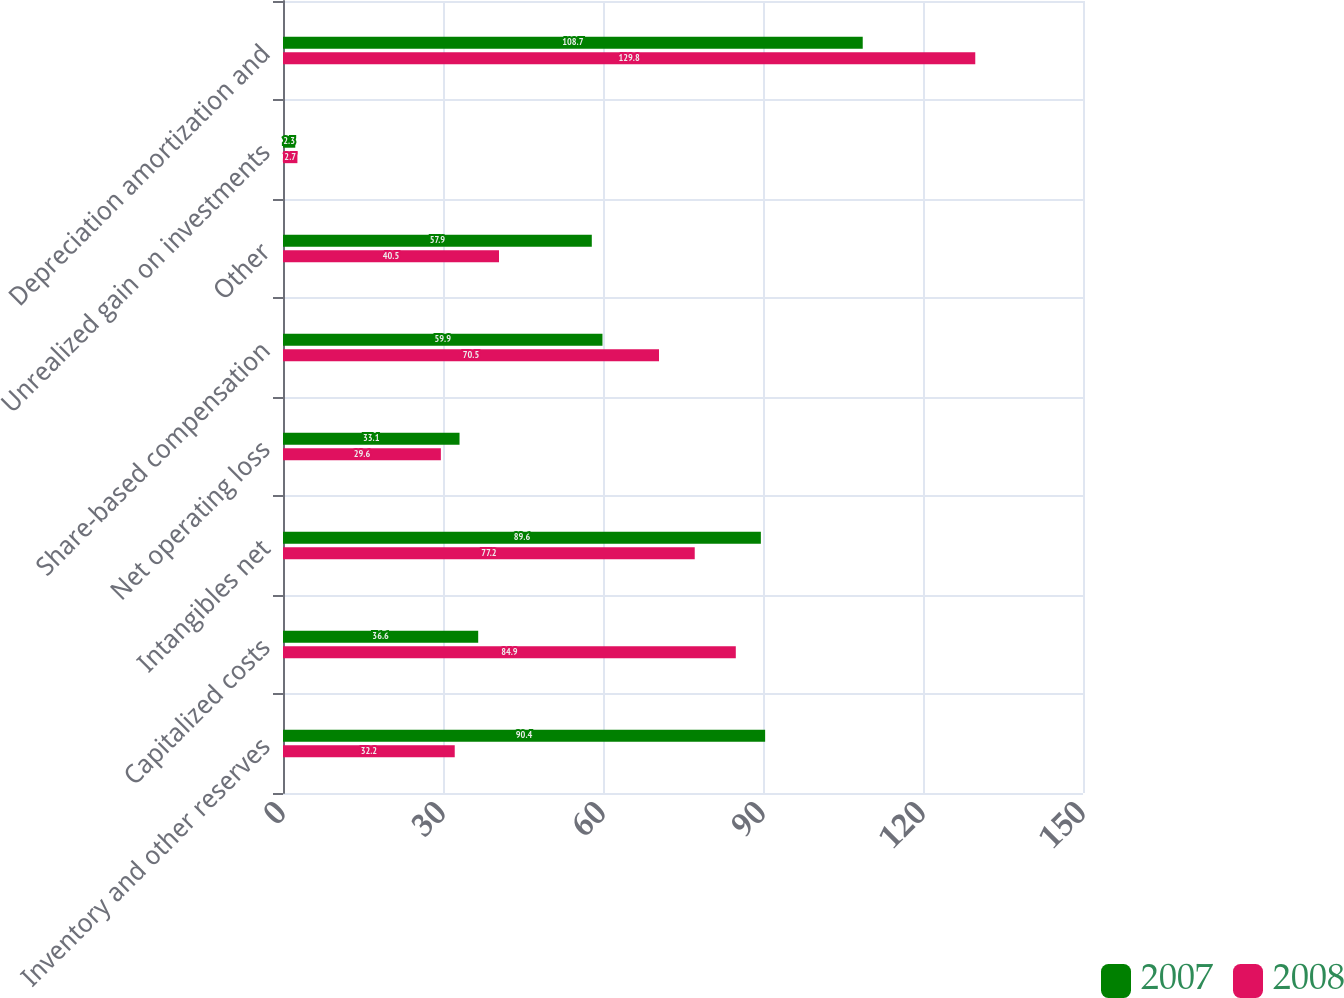Convert chart. <chart><loc_0><loc_0><loc_500><loc_500><stacked_bar_chart><ecel><fcel>Inventory and other reserves<fcel>Capitalized costs<fcel>Intangibles net<fcel>Net operating loss<fcel>Share-based compensation<fcel>Other<fcel>Unrealized gain on investments<fcel>Depreciation amortization and<nl><fcel>2007<fcel>90.4<fcel>36.6<fcel>89.6<fcel>33.1<fcel>59.9<fcel>57.9<fcel>2.3<fcel>108.7<nl><fcel>2008<fcel>32.2<fcel>84.9<fcel>77.2<fcel>29.6<fcel>70.5<fcel>40.5<fcel>2.7<fcel>129.8<nl></chart> 